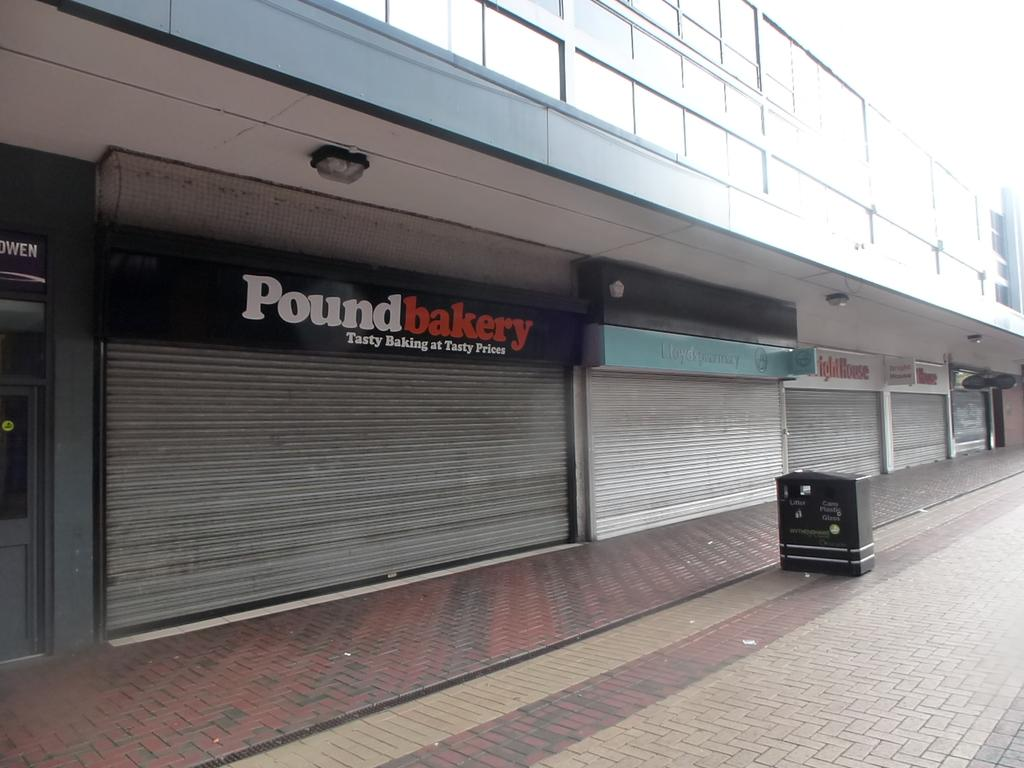<image>
Create a compact narrative representing the image presented. All the shops are closed including the Pound Bakery. 